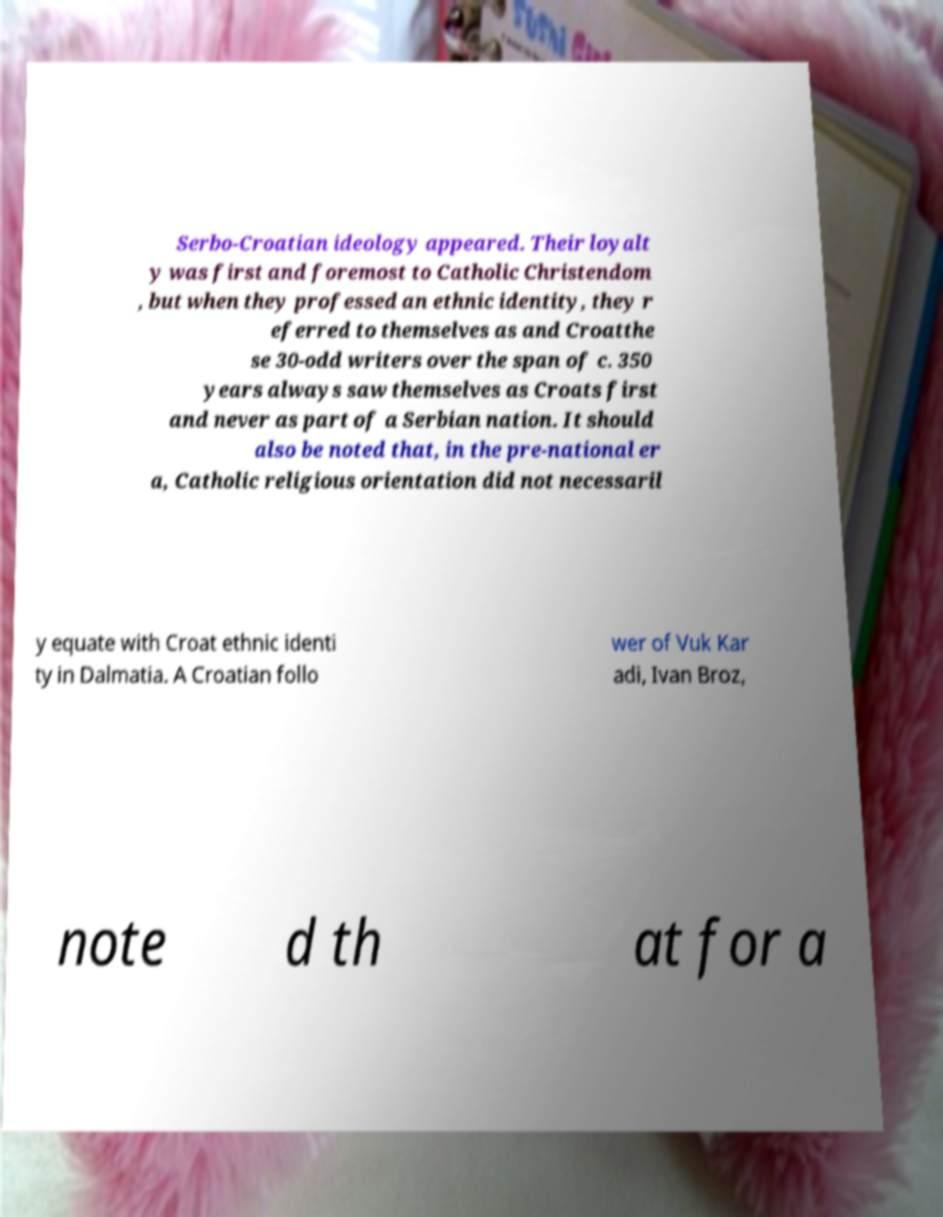Could you extract and type out the text from this image? Serbo-Croatian ideology appeared. Their loyalt y was first and foremost to Catholic Christendom , but when they professed an ethnic identity, they r eferred to themselves as and Croatthe se 30-odd writers over the span of c. 350 years always saw themselves as Croats first and never as part of a Serbian nation. It should also be noted that, in the pre-national er a, Catholic religious orientation did not necessaril y equate with Croat ethnic identi ty in Dalmatia. A Croatian follo wer of Vuk Kar adi, Ivan Broz, note d th at for a 